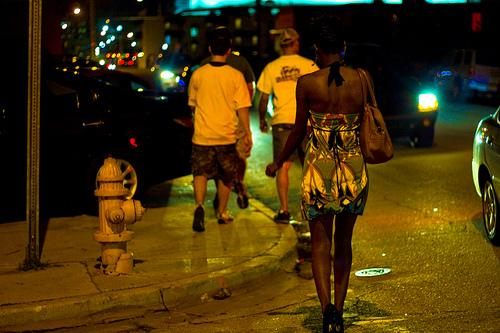Recount, in a sentence or two, the primary subject's activity in the picture. A woman, dressed in a chic attire, strides confidently along the street, carrying a purse on her shoulder. State the most important object in the image and describe their action. A woman, wearing a fashionable dress, strolls on the street carrying a purse. Write a succinct summary of the main activity seen in the image. A lady in a trendy dress walks on a city street, clutching her stylish purse. Provide a concise description of the most noticeable subject and their activity in the image. A well-dressed woman is spotted walking down the street, her purse in tow. Characterize the main subject and the action happening in the image with a brief description. A woman donning a stylish dress confidently navigates the city streets, her purse resting securely on her shoulder. In a descriptive sentence, state what the central focus of the image is doing. A female pedestrian, dressed elegantly, strolls down the street holding a purse. From the image, outline the main object and its related activity. The main object is a woman wearing a dress, walking down the street while holding her purse. Narrate a short scene describing the most important subject and their activities in the image. In a busy city street, a woman, clad in a fashionable dress, gracefully walks along carrying a purse on her shoulder.  Write a brief sentence summing up the most significant person and their action in the image. A stylishly dressed woman ambles along a city street, with a purse on her shoulder. Identify the primary object in the image and briefly describe its action. A woman wearing a dress is walking on the street while carrying a purse. 